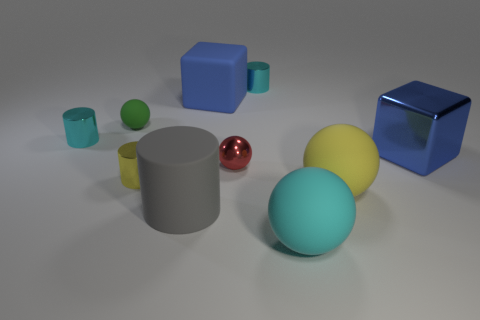Does the green rubber ball have the same size as the red metal ball?
Offer a very short reply. Yes. There is a cube that is to the right of the red metal sphere; is its color the same as the big matte cube?
Make the answer very short. Yes. What number of metallic cylinders are to the left of the tiny yellow metal cylinder?
Provide a succinct answer. 1. Is the number of big gray matte cylinders greater than the number of large blue metal cylinders?
Offer a very short reply. Yes. There is a thing that is to the right of the red shiny thing and behind the small green thing; what is its shape?
Your response must be concise. Cylinder. Is there a small shiny thing?
Ensure brevity in your answer.  Yes. There is a green object that is the same shape as the large yellow matte thing; what is its material?
Provide a short and direct response. Rubber. What is the shape of the big blue object behind the small cyan metallic cylinder that is in front of the matte sphere that is behind the big blue metal thing?
Give a very brief answer. Cube. What material is the big thing that is the same color as the large metallic cube?
Your answer should be very brief. Rubber. What number of tiny cyan things are the same shape as the big blue matte object?
Give a very brief answer. 0. 